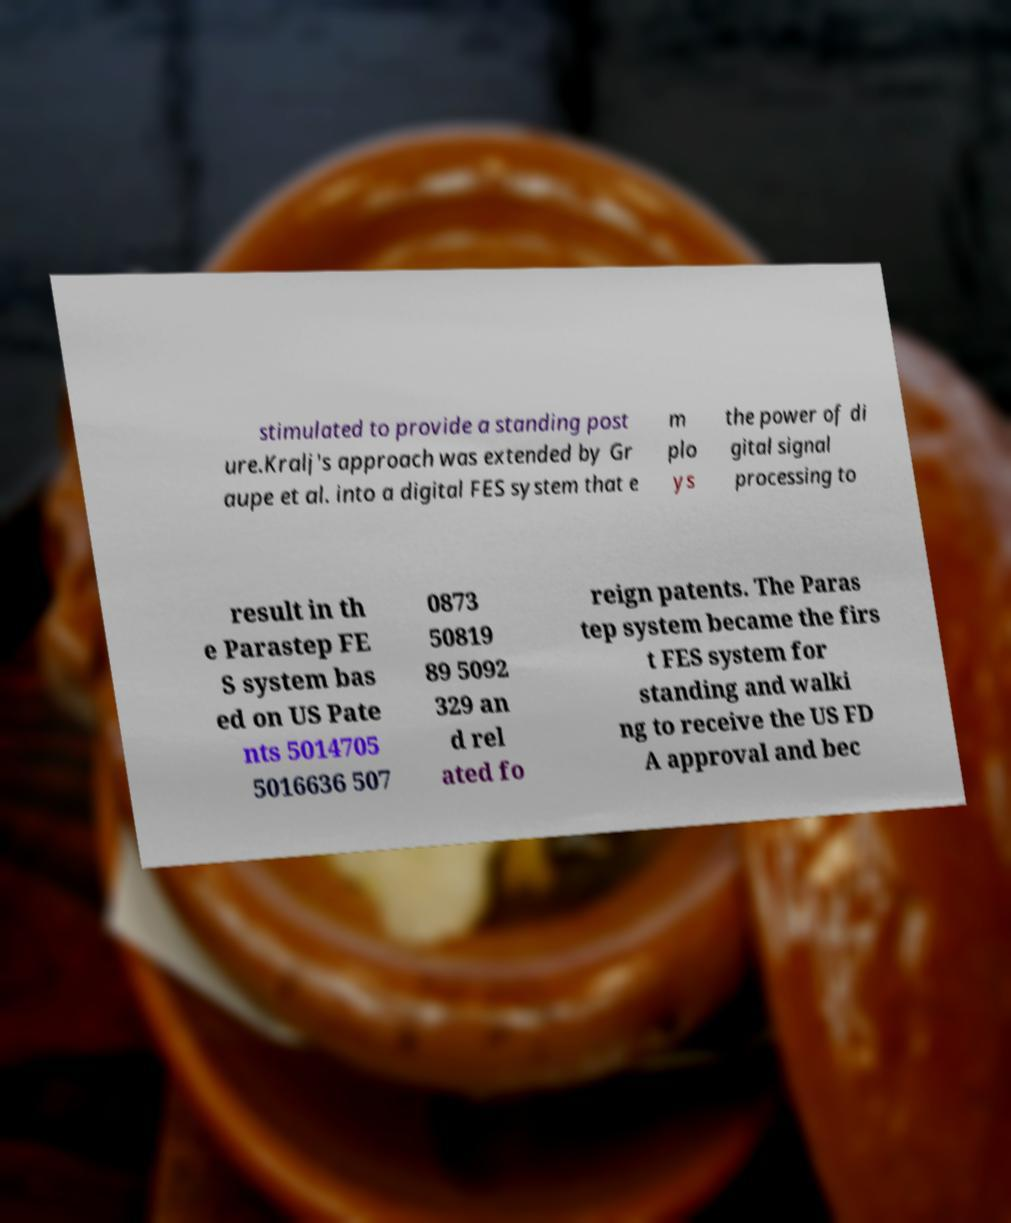What messages or text are displayed in this image? I need them in a readable, typed format. stimulated to provide a standing post ure.Kralj's approach was extended by Gr aupe et al. into a digital FES system that e m plo ys the power of di gital signal processing to result in th e Parastep FE S system bas ed on US Pate nts 5014705 5016636 507 0873 50819 89 5092 329 an d rel ated fo reign patents. The Paras tep system became the firs t FES system for standing and walki ng to receive the US FD A approval and bec 